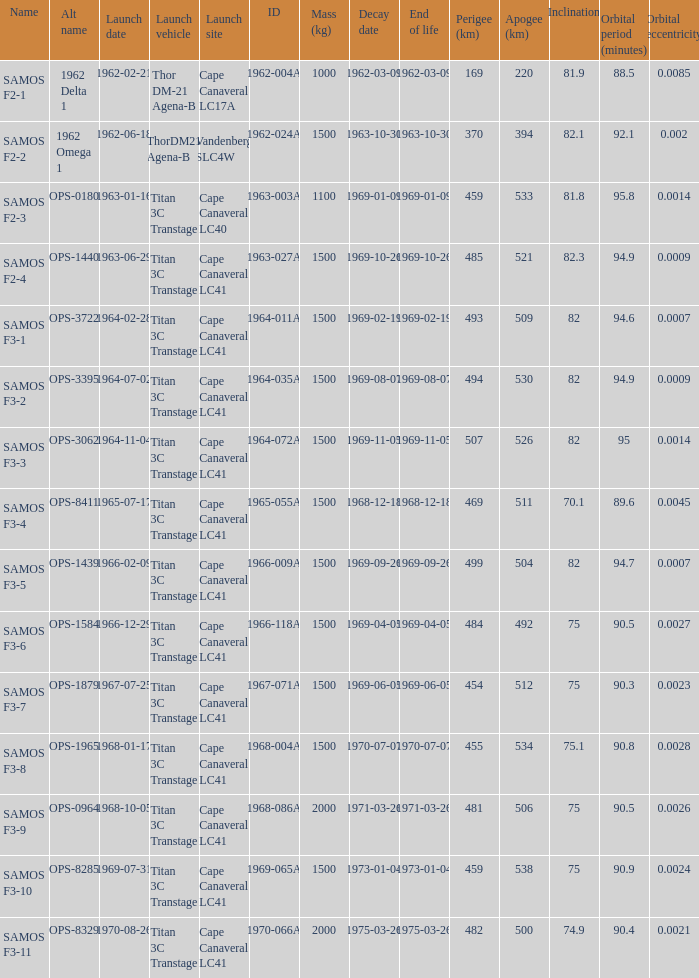What is the angle of inclination when the alternative designation is ops-1584? 75.0. 